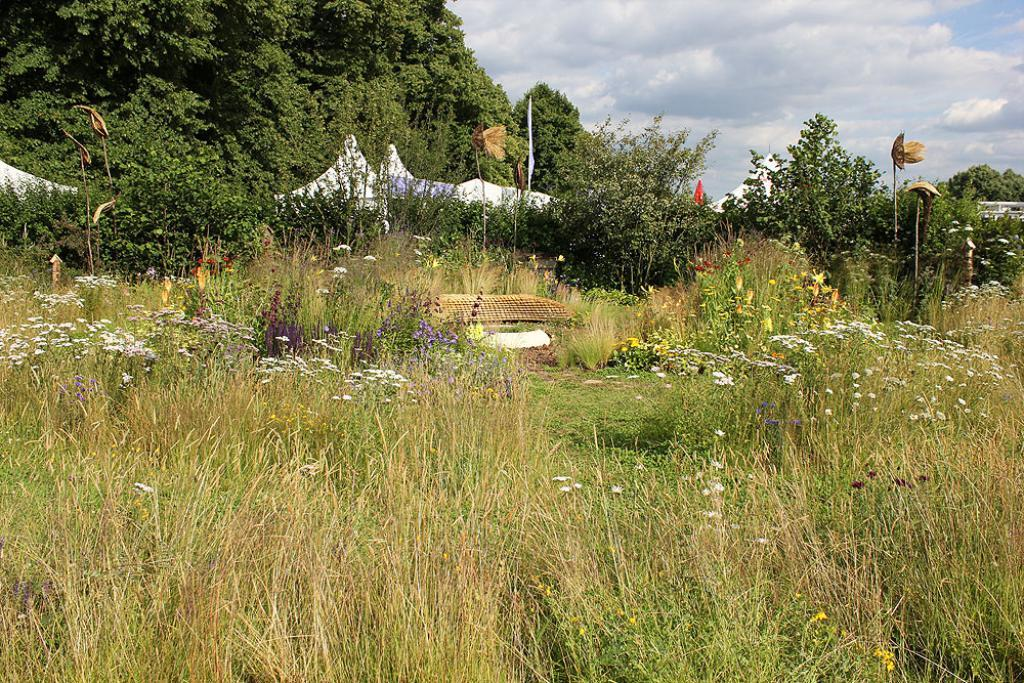What type of vegetation can be seen in the image? There is grass, flowers, and small plants in the image. What structures are present in the image? There are tents in the image. What type of natural environment is visible in the image? There are trees in the image, and the sky is visible in the background. What can be seen in the sky in the image? There are clouds in the sky. Where is the dad in the image? There is no dad present in the image. What direction is the army coming from in the image? There is no army present in the image. 